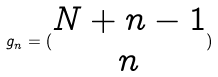<formula> <loc_0><loc_0><loc_500><loc_500>g _ { n } = ( \begin{matrix} N + n - 1 \\ n \end{matrix} )</formula> 